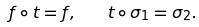<formula> <loc_0><loc_0><loc_500><loc_500>f \circ t = f , \quad t \circ \sigma _ { 1 } = \sigma _ { 2 } .</formula> 